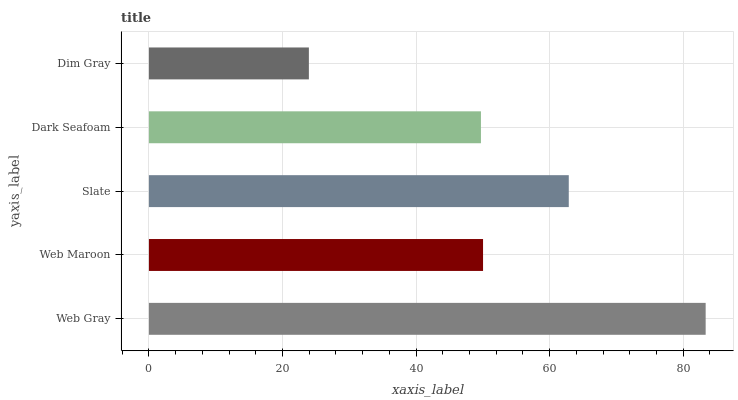Is Dim Gray the minimum?
Answer yes or no. Yes. Is Web Gray the maximum?
Answer yes or no. Yes. Is Web Maroon the minimum?
Answer yes or no. No. Is Web Maroon the maximum?
Answer yes or no. No. Is Web Gray greater than Web Maroon?
Answer yes or no. Yes. Is Web Maroon less than Web Gray?
Answer yes or no. Yes. Is Web Maroon greater than Web Gray?
Answer yes or no. No. Is Web Gray less than Web Maroon?
Answer yes or no. No. Is Web Maroon the high median?
Answer yes or no. Yes. Is Web Maroon the low median?
Answer yes or no. Yes. Is Dark Seafoam the high median?
Answer yes or no. No. Is Web Gray the low median?
Answer yes or no. No. 